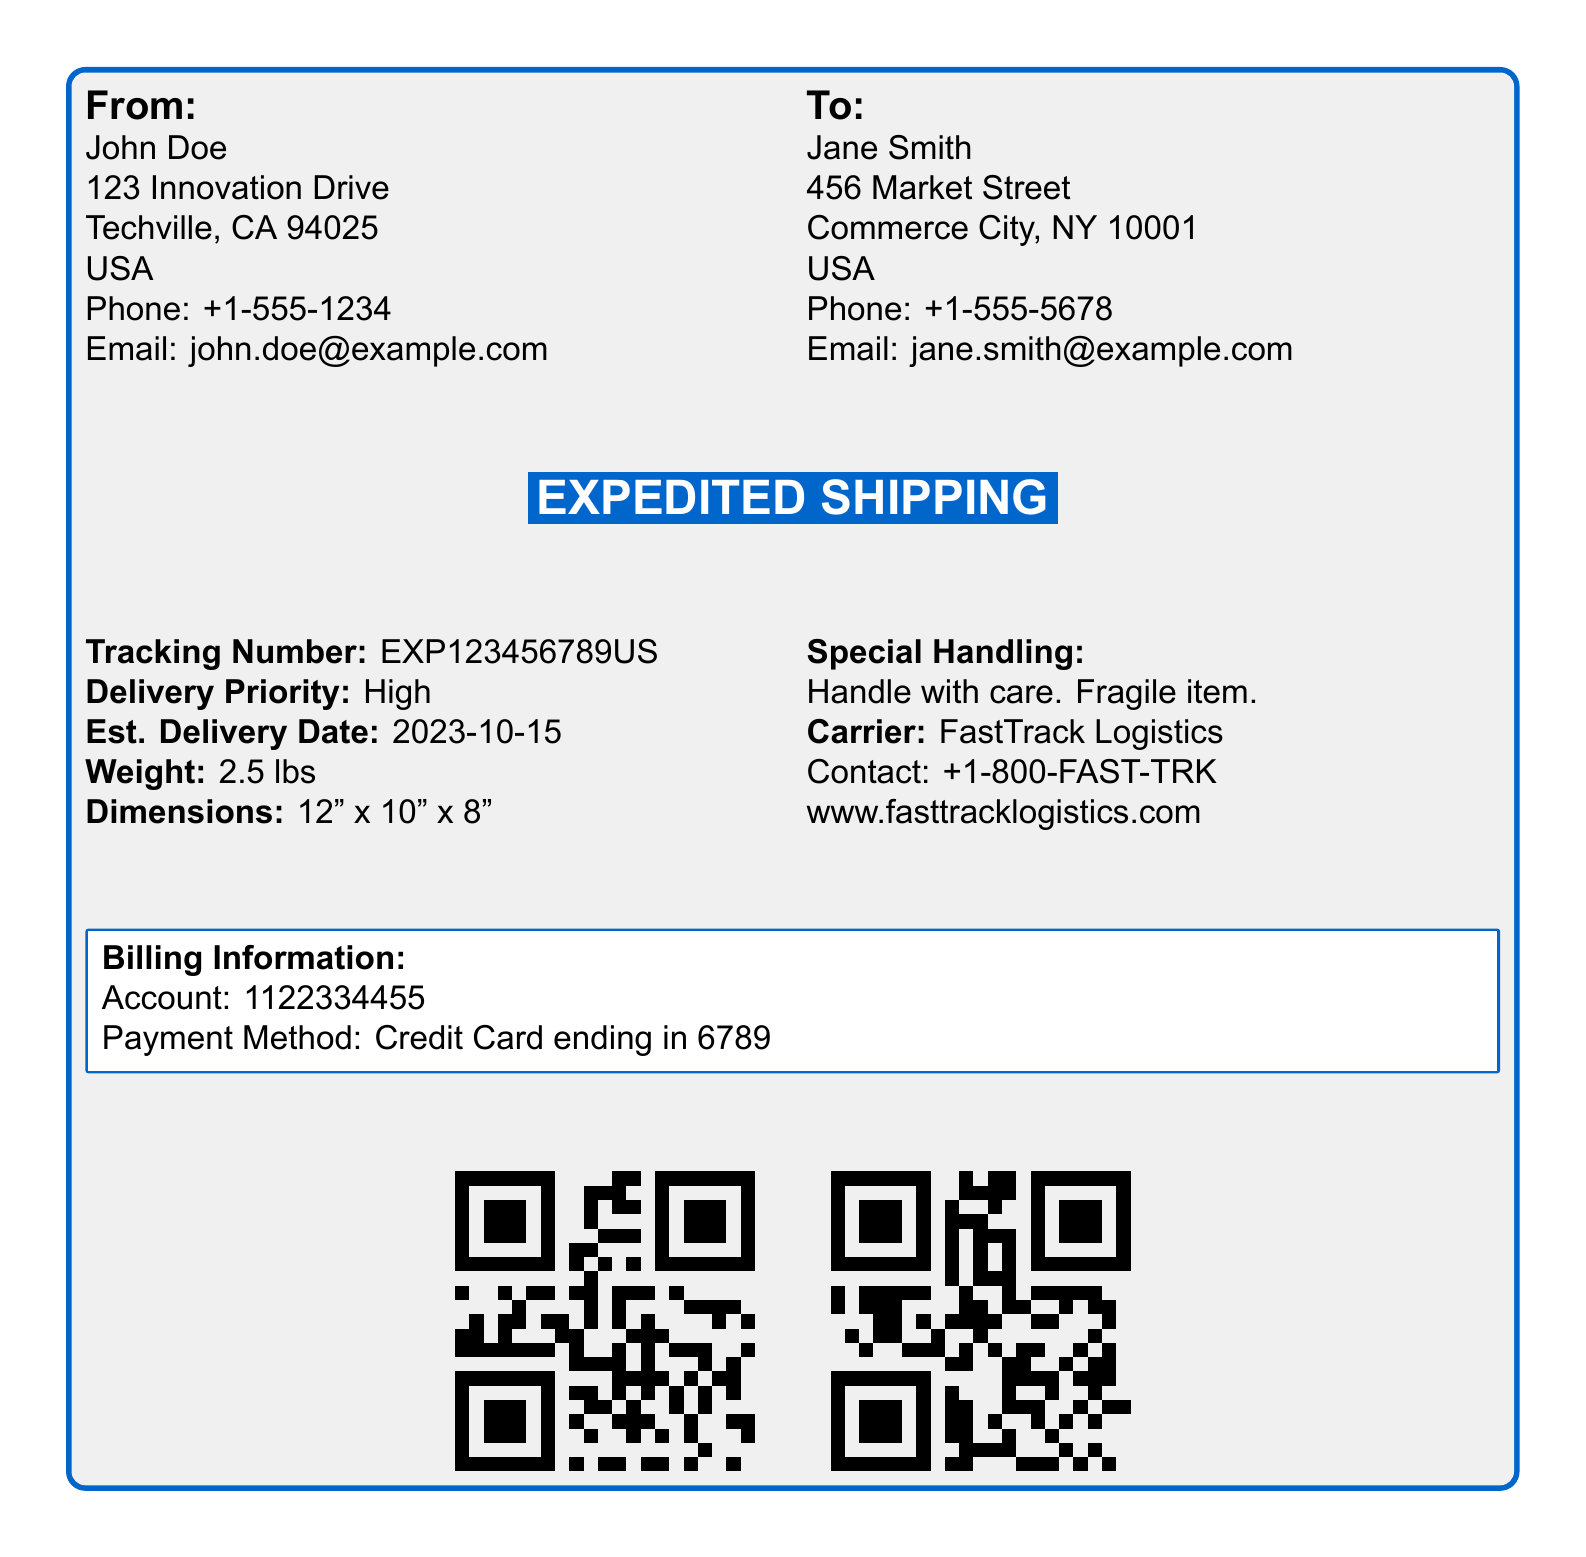What is the name of the sender? The sender's name is specified in the "From" section of the document.
Answer: John Doe What is the estimated delivery date? This date is given under "Est. Delivery Date" and indicates when the package is expected to arrive.
Answer: 2023-10-15 What is the tracking number? The tracking number is listed in the document and is essential for monitoring the shipment.
Answer: EXP123456789US What special handling instruction is provided? This instruction under "Special Handling" specifies how the package should be treated during transit.
Answer: Handle with care. Fragile item What is the delivery priority of this shipment? The priority level can be found next to "Delivery Priority," indicating the urgency of the delivery.
Answer: High Who is the carrier for this shipment? The carrier is mentioned in the "Carrier" section, identifying the company responsible for delivery.
Answer: FastTrack Logistics What are the dimensions of the package? The dimensions are listed in the shipping label and are essential for understanding the size of the shipment.
Answer: 12" x 10" x 8" What is the weight of the package? The weight is specified in the document and is vital for shipping costs and handling.
Answer: 2.5 lbs What is the billing account number? The account number is found in the "Billing Information" section of the document, crucial for payment processing.
Answer: 1122334455 